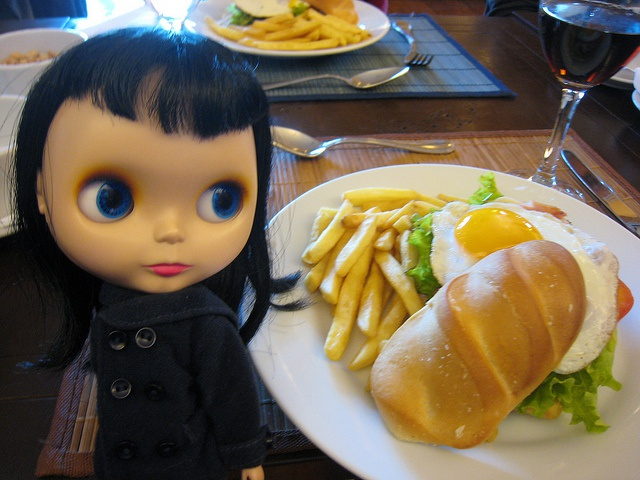Describe the objects in this image and their specific colors. I can see people in black, tan, and navy tones, dining table in black, maroon, and gray tones, sandwich in black, olive, lightgray, and tan tones, wine glass in black, gray, and blue tones, and bowl in black, darkgray, and gray tones in this image. 